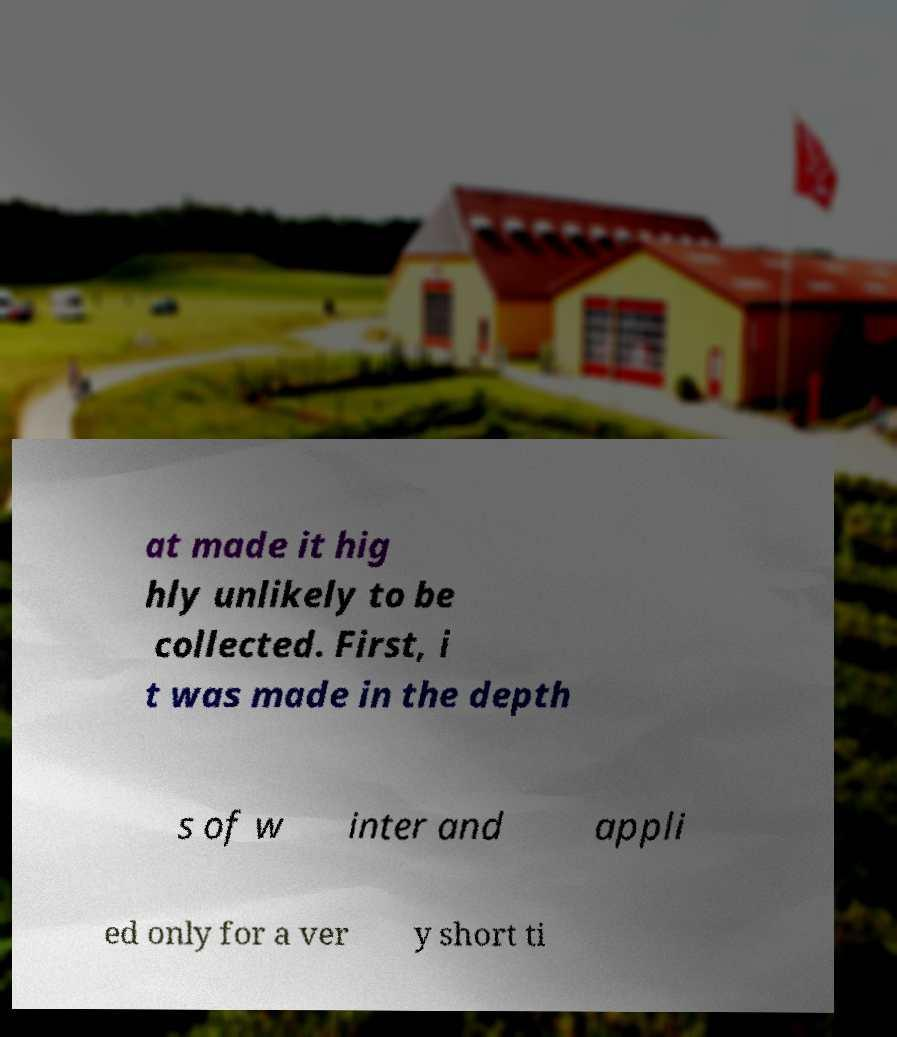Can you read and provide the text displayed in the image?This photo seems to have some interesting text. Can you extract and type it out for me? at made it hig hly unlikely to be collected. First, i t was made in the depth s of w inter and appli ed only for a ver y short ti 